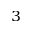Convert formula to latex. <formula><loc_0><loc_0><loc_500><loc_500>^ { 3 }</formula> 